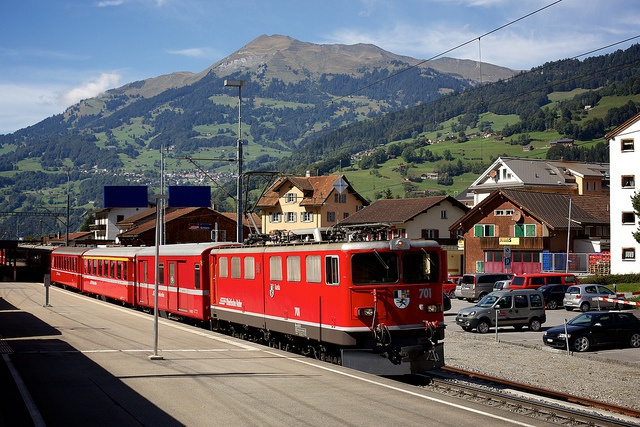Describe the objects in this image and their specific colors. I can see train in gray, black, red, and maroon tones, car in gray, black, navy, and darkgray tones, car in gray, black, and darkgray tones, car in gray, black, darkgray, and lightgray tones, and car in gray, black, and darkgray tones in this image. 